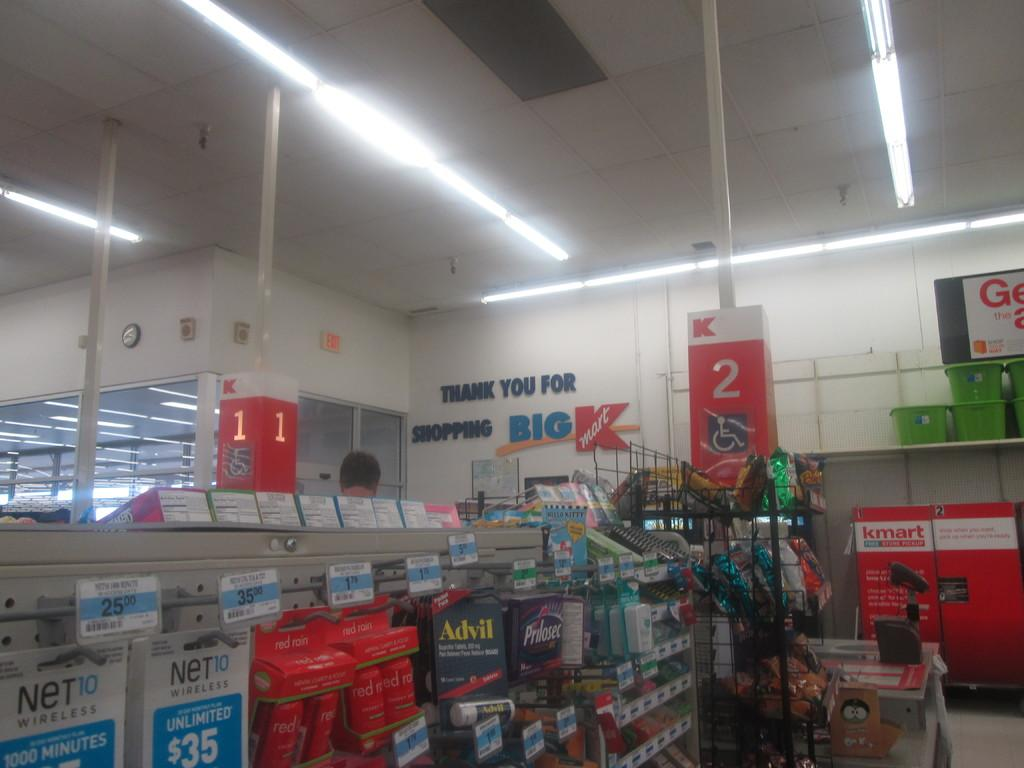<image>
Write a terse but informative summary of the picture. Checkout line number 2 in a Kmart store. 